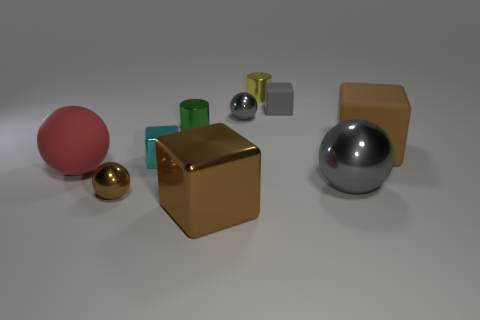There is a tiny metal thing that is the same color as the large shiny ball; what is its shape?
Ensure brevity in your answer.  Sphere. What is the material of the thing that is on the left side of the large brown shiny cube and behind the brown matte cube?
Ensure brevity in your answer.  Metal. What number of cylinders are either brown matte things or big gray shiny things?
Provide a short and direct response. 0. What material is the other large thing that is the same shape as the large red matte thing?
Offer a very short reply. Metal. There is a cylinder that is made of the same material as the green thing; what is its size?
Your response must be concise. Small. There is a large rubber object that is behind the cyan metal block; does it have the same shape as the gray shiny object that is on the left side of the big gray ball?
Make the answer very short. No. What is the color of the big cube that is the same material as the big red object?
Make the answer very short. Brown. There is a metal cylinder to the left of the tiny yellow cylinder; does it have the same size as the metallic sphere behind the small metal cube?
Your answer should be compact. Yes. There is a brown thing that is both right of the brown metal ball and left of the tiny rubber object; what shape is it?
Make the answer very short. Cube. Are there any small cyan spheres made of the same material as the tiny cyan thing?
Your answer should be compact. No. 